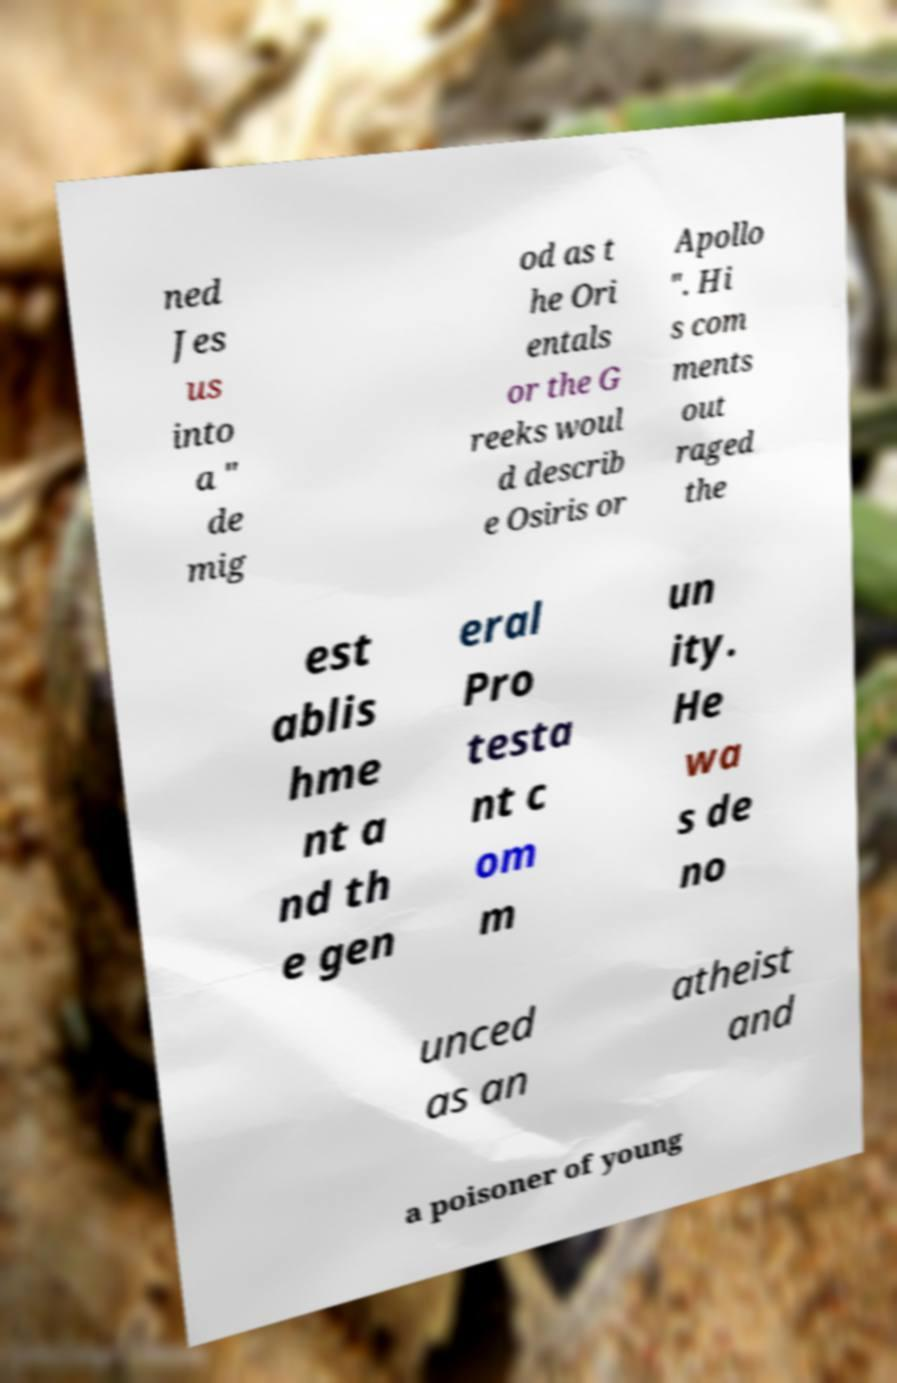Could you extract and type out the text from this image? ned Jes us into a " de mig od as t he Ori entals or the G reeks woul d describ e Osiris or Apollo ". Hi s com ments out raged the est ablis hme nt a nd th e gen eral Pro testa nt c om m un ity. He wa s de no unced as an atheist and a poisoner of young 